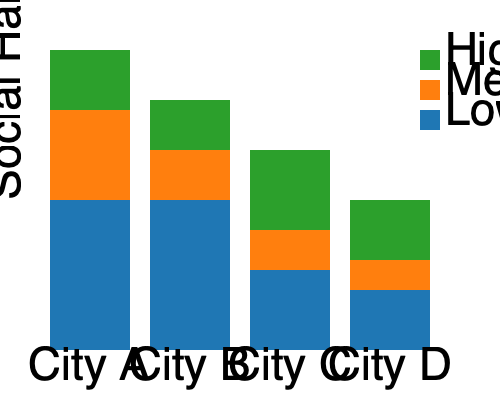Based on the stacked bar chart showing the relationship between religious diversity and social harmony in four cities, which city demonstrates the highest level of social harmony despite having the lowest religious diversity? To answer this question, we need to analyze the stacked bar chart for each city:

1. Understand the chart:
   - The y-axis represents the Social Harmony Index.
   - Each bar is divided into three sections representing different levels of religious diversity (high, medium, low).
   - The total height of each bar indicates the overall social harmony level for that city.

2. Analyze each city:
   - City A: Has the shortest overall bar, indicating the lowest social harmony.
   - City B: Has the tallest overall bar, indicating the highest social harmony.
   - City C: Has the second-tallest bar, indicating the second-highest social harmony.
   - City D: Has the third-tallest bar, indicating the third-highest social harmony.

3. Examine religious diversity:
   - The blue section at the bottom of each bar represents low religious diversity.
   - City B has the largest blue section, indicating it has the lowest religious diversity among the four cities.

4. Compare social harmony and diversity:
   - City B simultaneously has the highest social harmony (tallest overall bar) and the lowest religious diversity (largest blue section).

Therefore, City B demonstrates the highest level of social harmony despite having the lowest religious diversity.
Answer: City B 